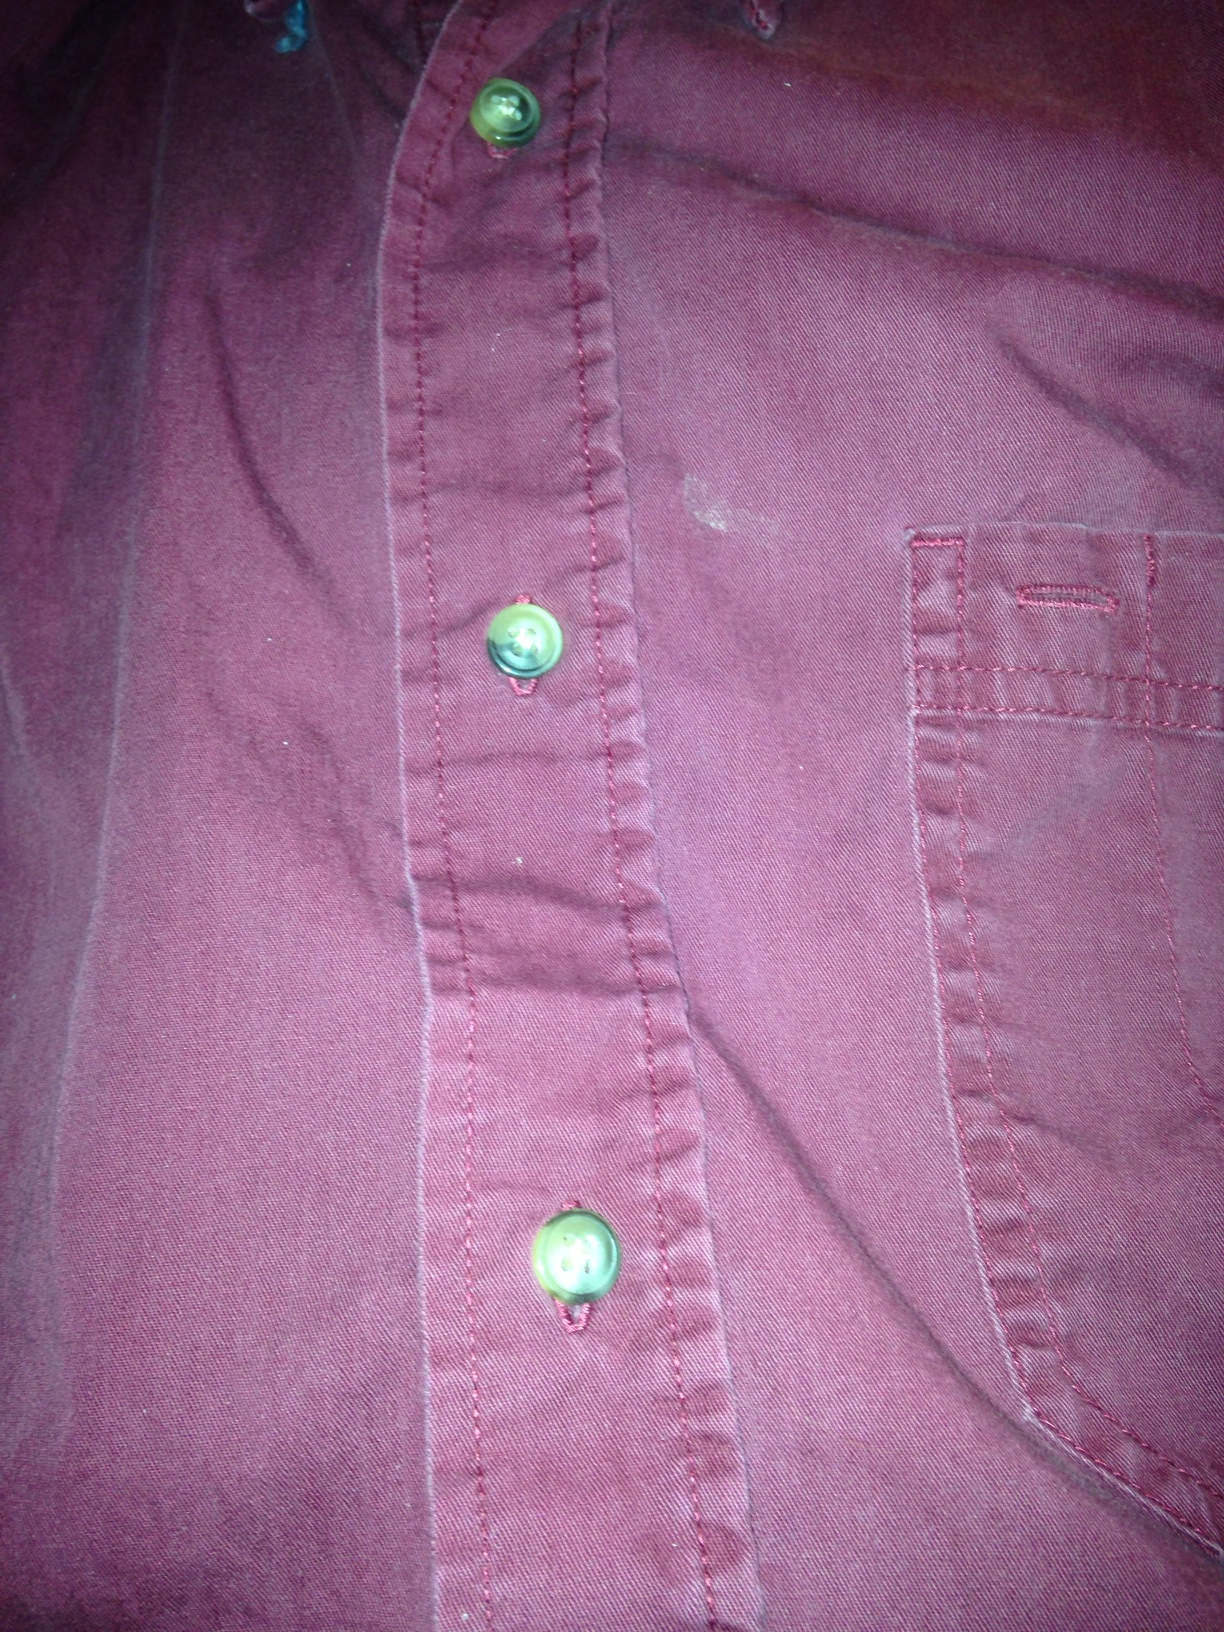What color is this shirt? The shirt appears to be a deep reddish color, typically referred to as maroon. It features a slightly faded look, possibly due to wear or the nature of the fabric, which adds a casual, vintage aesthetic to it. 